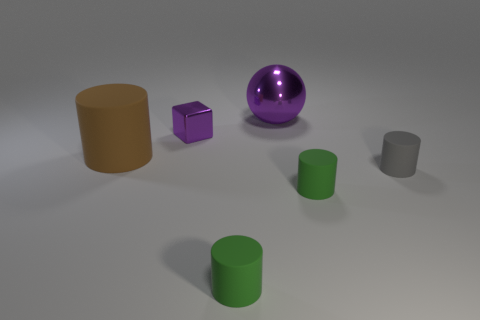There is a big thing that is behind the brown cylinder; what is its color?
Make the answer very short. Purple. What number of other things are there of the same color as the large ball?
Make the answer very short. 1. There is a purple metallic block that is in front of the metal sphere; does it have the same size as the purple metallic ball?
Offer a terse response. No. There is a large thing behind the small purple block; what is its material?
Offer a very short reply. Metal. Is there any other thing that is the same shape as the large shiny thing?
Provide a short and direct response. No. How many rubber objects are either tiny cylinders or small blocks?
Your answer should be very brief. 3. Are there fewer spheres that are on the left side of the large metal ball than big green rubber things?
Ensure brevity in your answer.  No. There is a purple shiny thing that is on the right side of the small object behind the matte cylinder left of the cube; what shape is it?
Give a very brief answer. Sphere. Is the large metal sphere the same color as the small shiny block?
Keep it short and to the point. Yes. Are there more small purple metal objects than big brown balls?
Offer a very short reply. Yes. 